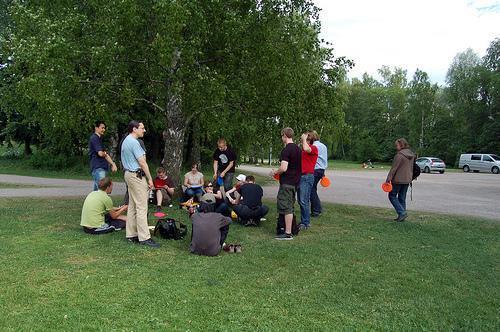How many people are standing?
Give a very brief answer. 7. 